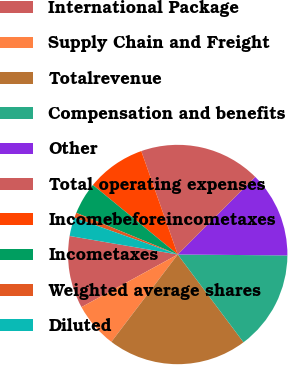Convert chart to OTSL. <chart><loc_0><loc_0><loc_500><loc_500><pie_chart><fcel>International Package<fcel>Supply Chain and Freight<fcel>Totalrevenue<fcel>Compensation and benefits<fcel>Other<fcel>Total operating expenses<fcel>Incomebeforeincometaxes<fcel>Incometaxes<fcel>Weighted average shares<fcel>Diluted<nl><fcel>10.66%<fcel>6.7%<fcel>20.57%<fcel>14.63%<fcel>12.64%<fcel>17.88%<fcel>8.68%<fcel>4.72%<fcel>0.76%<fcel>2.74%<nl></chart> 